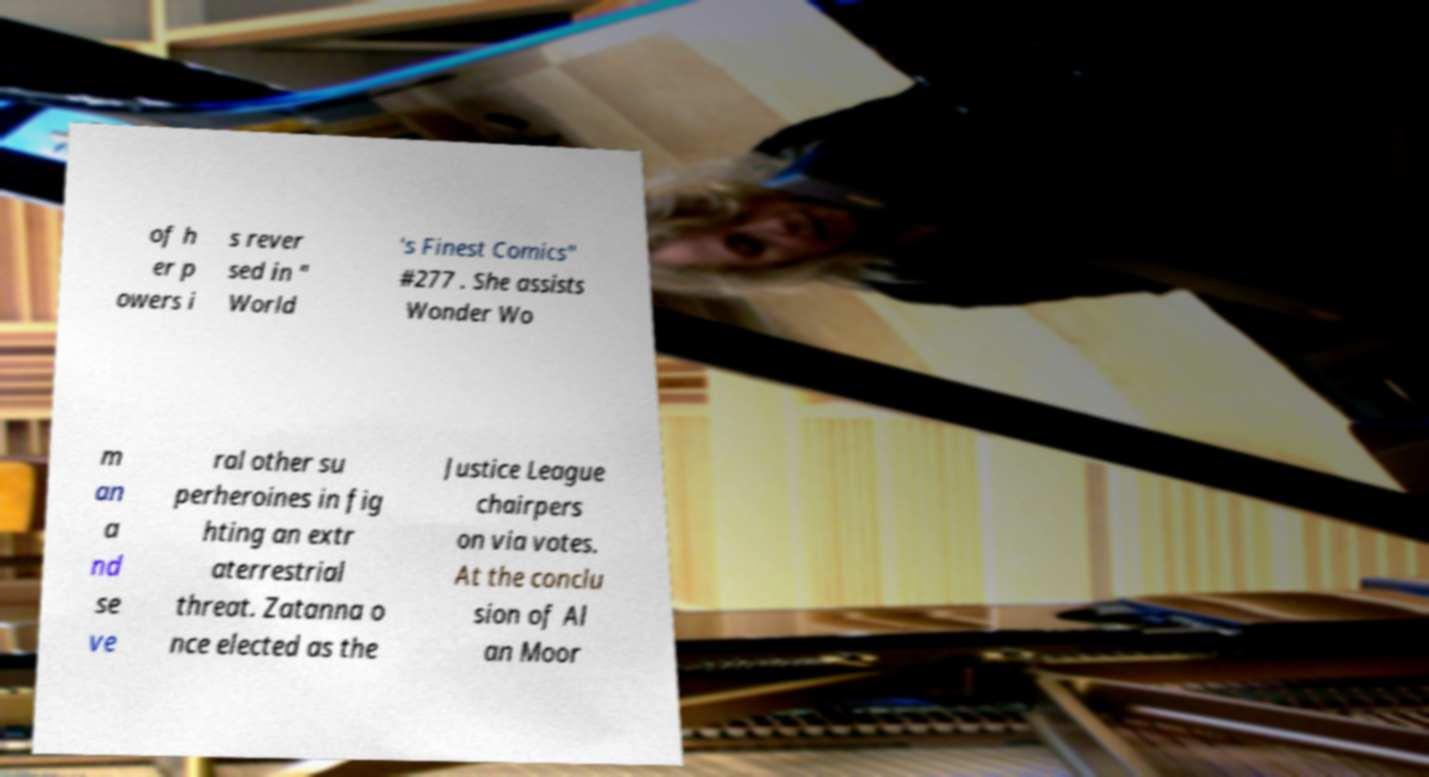What messages or text are displayed in this image? I need them in a readable, typed format. of h er p owers i s rever sed in " World 's Finest Comics" #277 . She assists Wonder Wo m an a nd se ve ral other su perheroines in fig hting an extr aterrestrial threat. Zatanna o nce elected as the Justice League chairpers on via votes. At the conclu sion of Al an Moor 